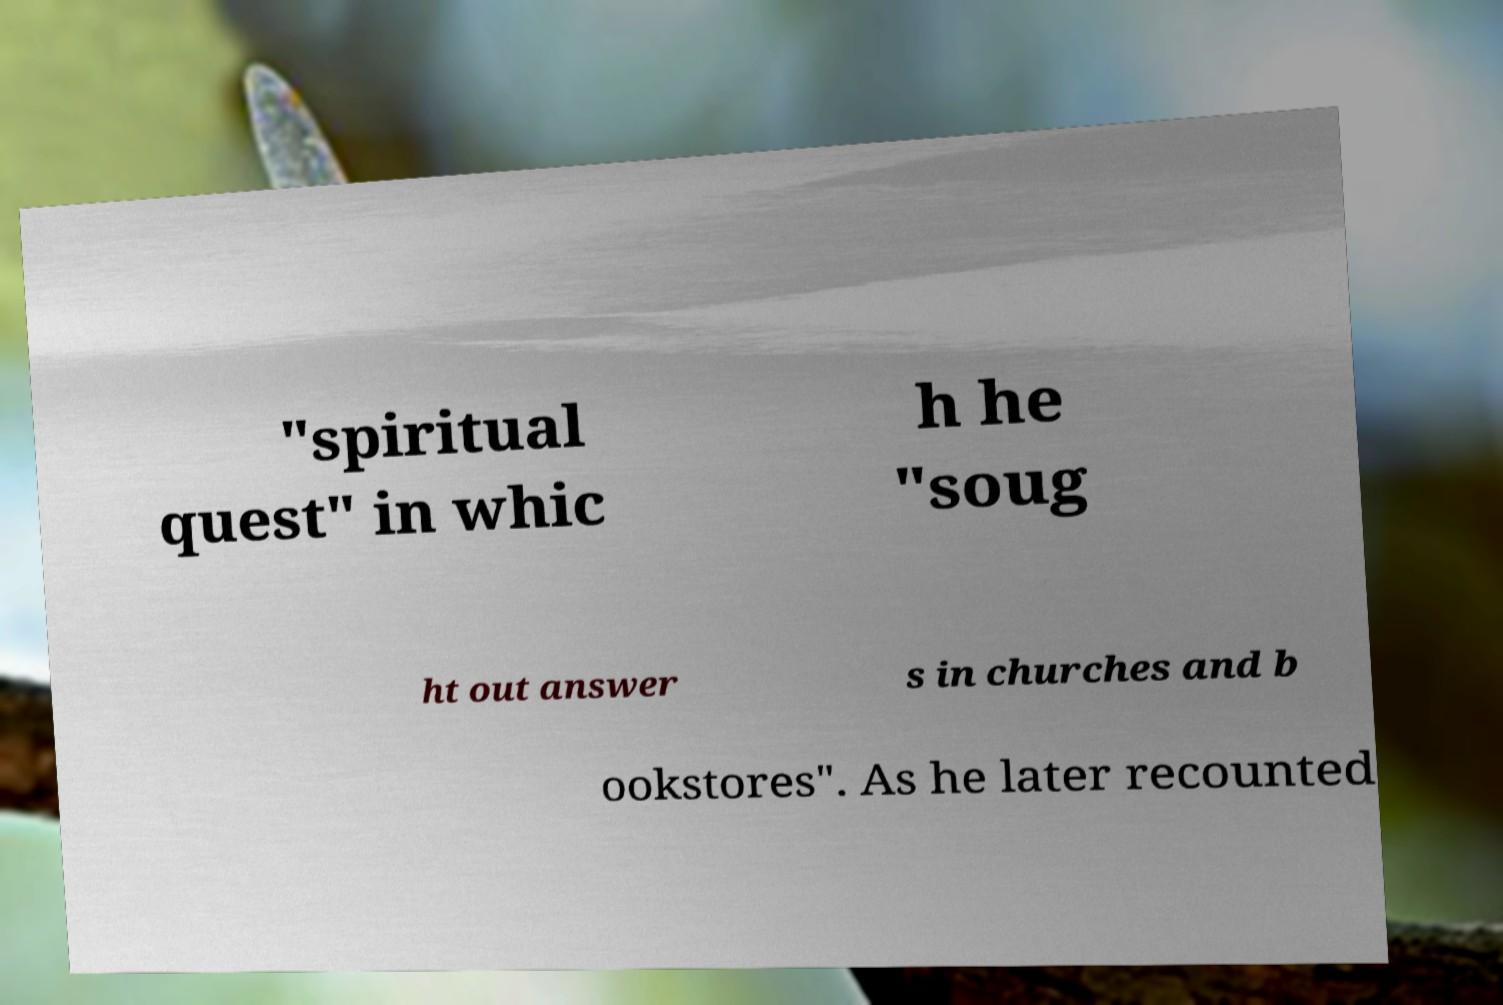There's text embedded in this image that I need extracted. Can you transcribe it verbatim? "spiritual quest" in whic h he "soug ht out answer s in churches and b ookstores". As he later recounted 